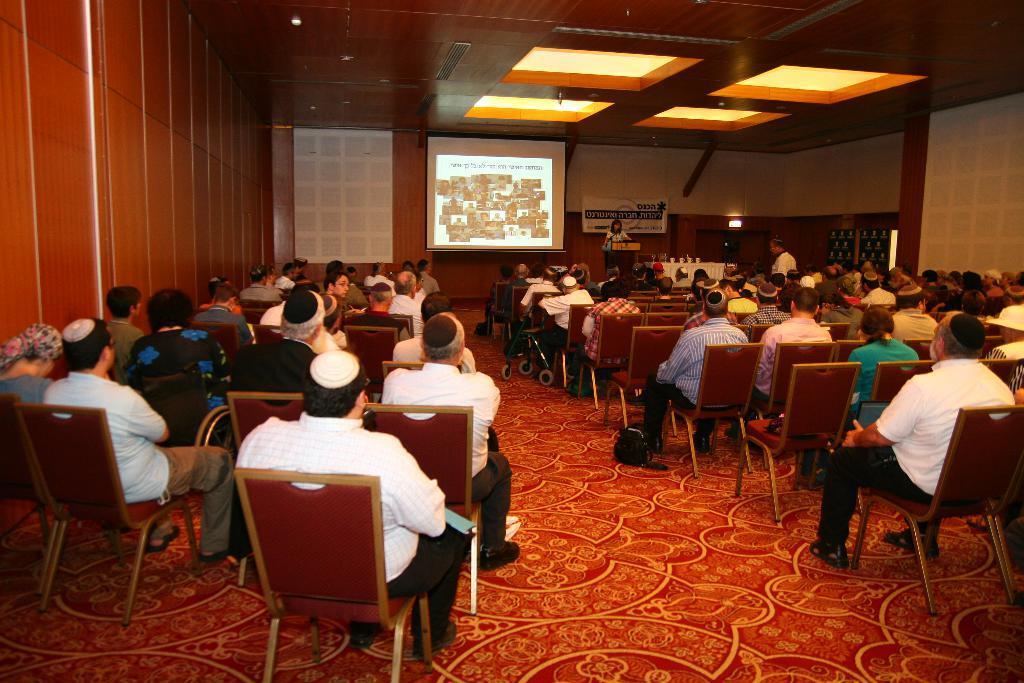How would you summarize this image in a sentence or two? In the hall there are people sitting on the chair. In front of them there is a lady standing in front of the podium. To the right side of her there is screen. And to the backside of her there is a poster. 